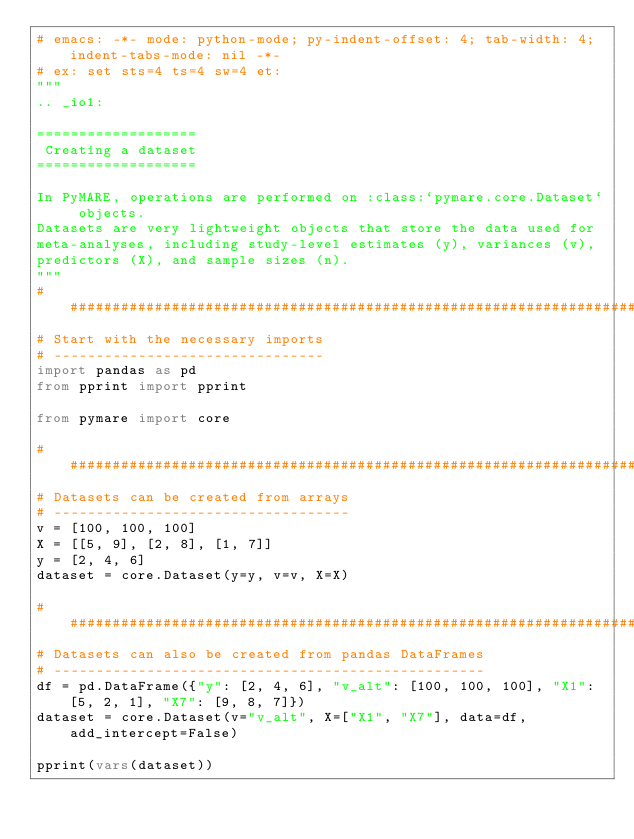Convert code to text. <code><loc_0><loc_0><loc_500><loc_500><_Python_># emacs: -*- mode: python-mode; py-indent-offset: 4; tab-width: 4; indent-tabs-mode: nil -*-
# ex: set sts=4 ts=4 sw=4 et:
"""
.. _io1:

===================
 Creating a dataset
===================

In PyMARE, operations are performed on :class:`pymare.core.Dataset` objects.
Datasets are very lightweight objects that store the data used for
meta-analyses, including study-level estimates (y), variances (v),
predictors (X), and sample sizes (n).
"""
###############################################################################
# Start with the necessary imports
# --------------------------------
import pandas as pd
from pprint import pprint

from pymare import core

###############################################################################
# Datasets can be created from arrays
# -----------------------------------
v = [100, 100, 100]
X = [[5, 9], [2, 8], [1, 7]]
y = [2, 4, 6]
dataset = core.Dataset(y=y, v=v, X=X)

###############################################################################
# Datasets can also be created from pandas DataFrames
# ---------------------------------------------------
df = pd.DataFrame({"y": [2, 4, 6], "v_alt": [100, 100, 100], "X1": [5, 2, 1], "X7": [9, 8, 7]})
dataset = core.Dataset(v="v_alt", X=["X1", "X7"], data=df, add_intercept=False)

pprint(vars(dataset))
</code> 